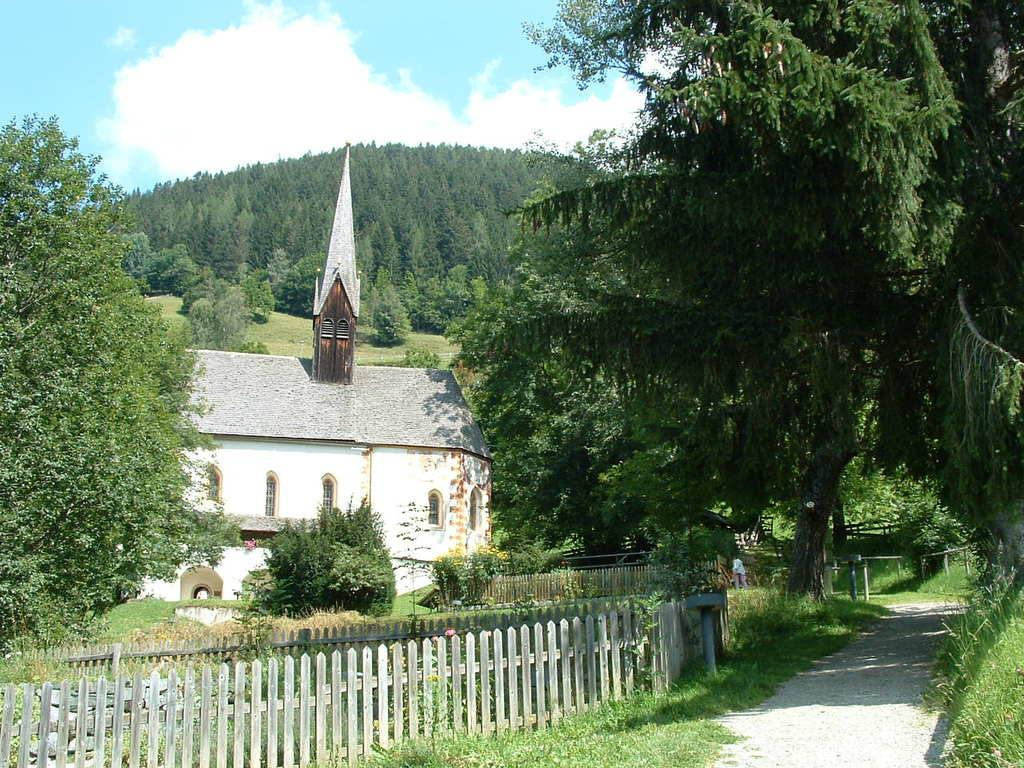What type of structure is visible in the image? There is a house in the image. Can you describe the person in the image? There is a person in the image. What type of vegetation is present in the image? There are trees in the image. What type of barrier can be seen in the image? There are fences in the image. What type of ground surface is visible in the image? There is grass in the image. What can be seen in the sky in the image? There are clouds in the sky in the image. Where is the bulb located in the image? There is no bulb present in the image. Can you see an airplane flying in the sky in the image? There is no airplane visible in the sky in the image. 